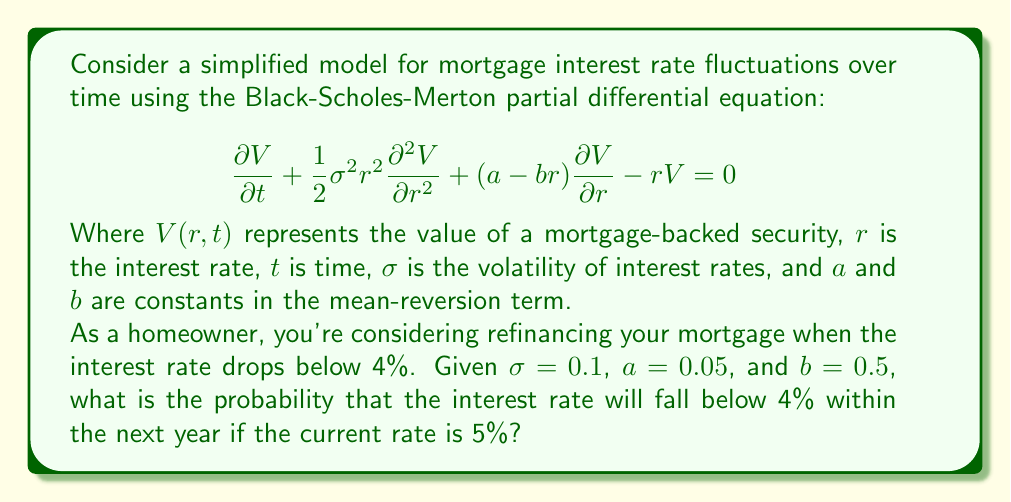Show me your answer to this math problem. To solve this problem, we need to use the concept of first passage time in stochastic processes, which is related to the Black-Scholes-Merton PDE given in the question. The steps to solve this are:

1) First, we recognize that the interest rate follows an Ornstein-Uhlenbeck process, which is mean-reverting:

   $$dr = (a - br)dt + \sigma dW$$

   Where $W$ is a Wiener process.

2) The probability we're looking for is related to the cumulative distribution function of the first passage time. This can be approximated using the method of images solution to the Fokker-Planck equation associated with the Ornstein-Uhlenbeck process.

3) The probability $P(t)$ that the interest rate has not yet reached the barrier (4% in this case) by time $t$ is given by:

   $$P(t) = \Phi\left(\frac{r_0 - r_f}{\sigma_\infty\sqrt{1-e^{-2bt}}}\right) - e^{-2a(r_0-r_f)/\sigma^2}\Phi\left(\frac{-r_0 + r_f e^{-bt}}{\sigma_\infty\sqrt{1-e^{-2bt}}}\right)$$

   Where $\Phi$ is the standard normal cumulative distribution function, $r_0$ is the initial rate (5%), $r_f$ is the barrier rate (4%), and $\sigma_\infty = \sigma\sqrt{\frac{1}{2b}}$.

4) Calculate $\sigma_\infty$:
   $$\sigma_\infty = 0.1\sqrt{\frac{1}{2(0.5)}} = 0.1$$

5) Now, we can calculate $P(1)$ (as we're interested in the probability within one year):

   $$P(1) = \Phi\left(\frac{0.05 - 0.04}{0.1\sqrt{1-e^{-2(0.5)(1)}}}\right) - e^{-2(0.05)(0.05-0.04)/0.1^2}\Phi\left(\frac{-0.05 + 0.04 e^{-0.5(1)}}{0.1\sqrt{1-e^{-2(0.5)(1)}}}\right)$$

6) This can be evaluated numerically to get the probability that the rate has not yet reached 4%.

7) The probability we want is 1 minus this value.
Answer: The probability that the interest rate will fall below 4% within the next year is approximately 0.3912 or 39.12%. 